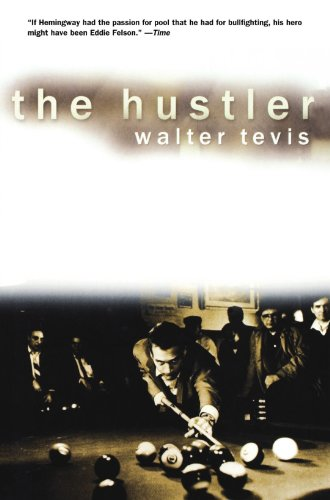What is the genre of this book? Although the book involves sports, namely billiards, it is primarily a drama with deep psychological and social overtones, delving into the complexities of its characters. 